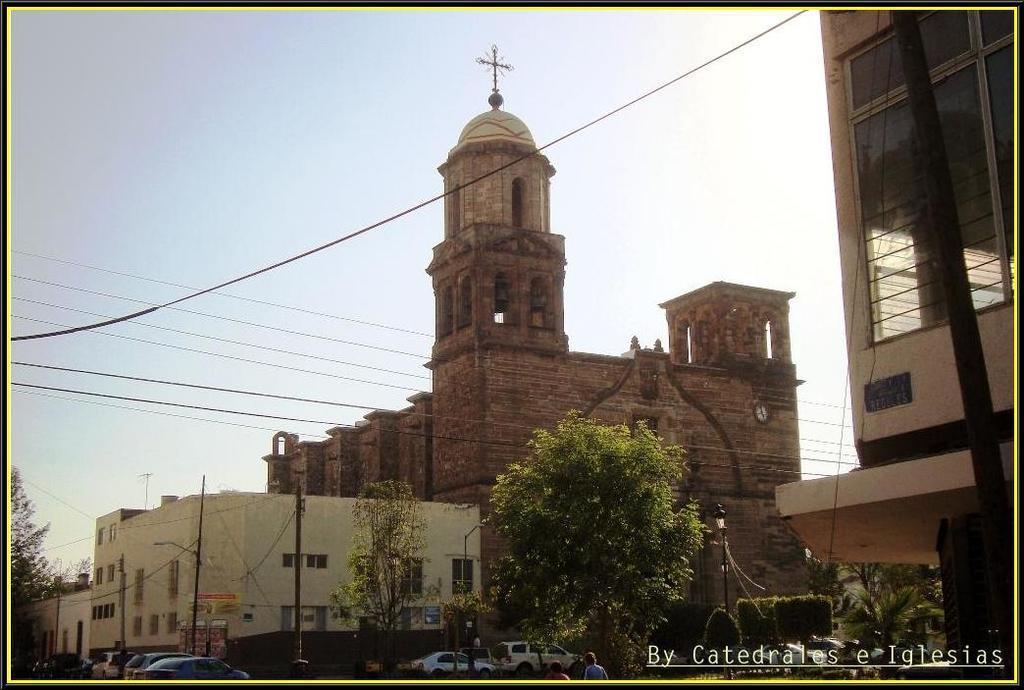Please provide a concise description of this image. There are vehicles, trees, poles and buildings are present at the bottom of this image and the sky is in the background. There is a watermark in the bottom right corner of this image. 